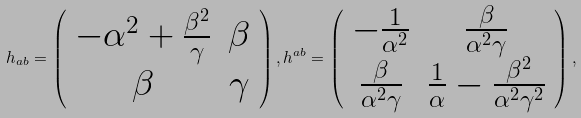<formula> <loc_0><loc_0><loc_500><loc_500>h _ { a b } = \left ( \begin{array} { c c } - \alpha ^ { 2 } + \frac { \beta ^ { 2 } } { \gamma } & \beta \\ \beta & \gamma \end{array} \right ) , h ^ { a b } = \left ( \begin{array} { c c } - \frac { 1 } { \alpha ^ { 2 } } & \frac { \beta } { \alpha ^ { 2 } \gamma } \\ \frac { \beta } { \alpha ^ { 2 } \gamma } & \frac { 1 } { \alpha } - \frac { \beta ^ { 2 } } { \alpha ^ { 2 } \gamma ^ { 2 } } \end{array} \right ) ,</formula> 